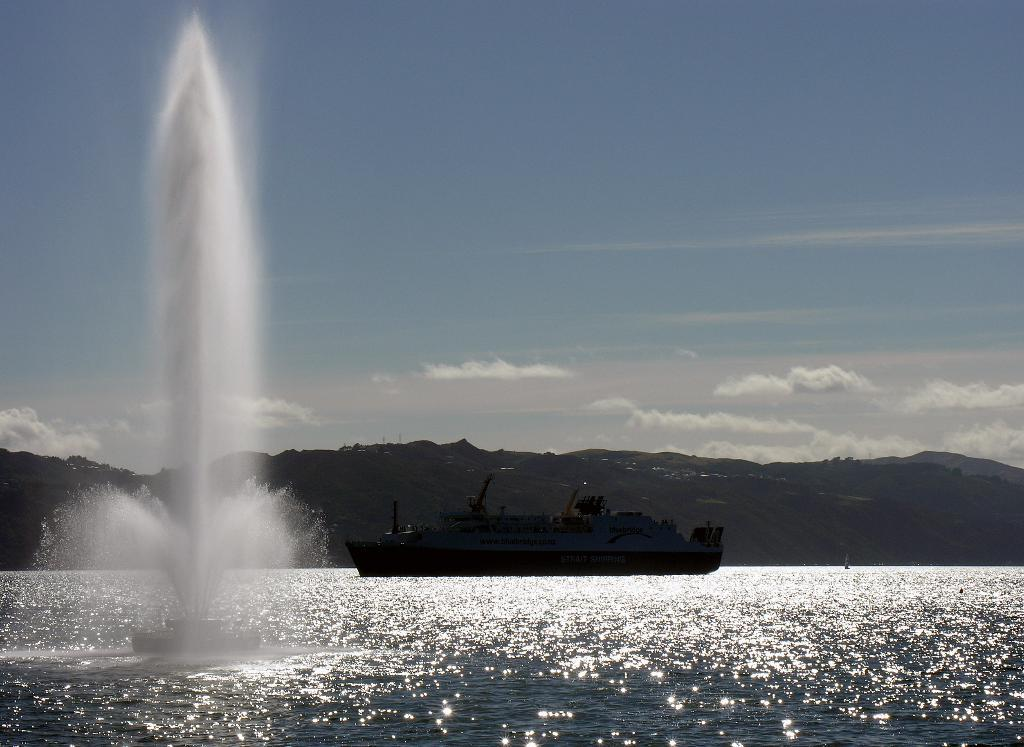What is the main subject of the image? There is a ship in the image. Where is the ship located? The ship is on the water. What other features can be seen in the image? There is a water fountain and hills visible in the background of the image. How would you describe the sky in the image? The sky is blue and cloudy. What type of toothpaste is being used to clean the owl's beak in the image? There is no toothpaste or owl present in the image. How many books can be seen on the ship in the image? There are no books visible in the image; it features a ship on the water with a water fountain and hills in the background. 